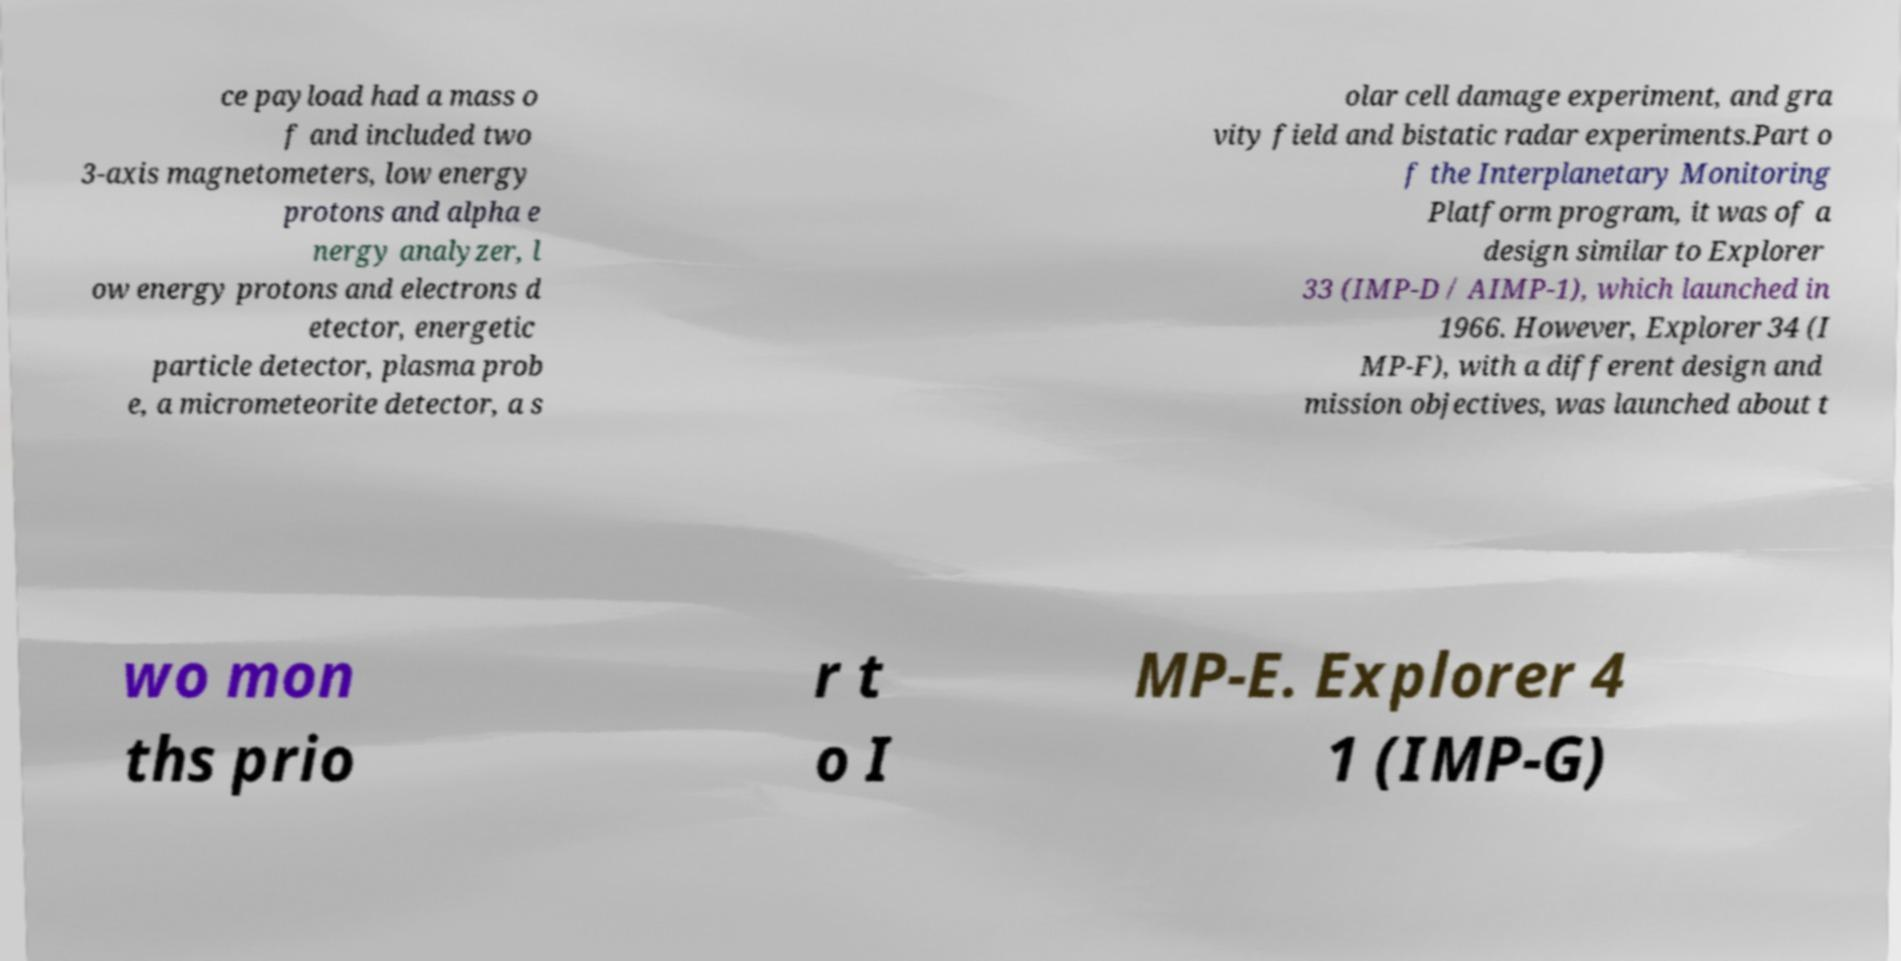For documentation purposes, I need the text within this image transcribed. Could you provide that? ce payload had a mass o f and included two 3-axis magnetometers, low energy protons and alpha e nergy analyzer, l ow energy protons and electrons d etector, energetic particle detector, plasma prob e, a micrometeorite detector, a s olar cell damage experiment, and gra vity field and bistatic radar experiments.Part o f the Interplanetary Monitoring Platform program, it was of a design similar to Explorer 33 (IMP-D / AIMP-1), which launched in 1966. However, Explorer 34 (I MP-F), with a different design and mission objectives, was launched about t wo mon ths prio r t o I MP-E. Explorer 4 1 (IMP-G) 